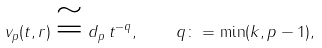<formula> <loc_0><loc_0><loc_500><loc_500>v _ { p } ( t , r ) \cong d _ { p } \, t ^ { - q } , \quad q \colon = \min ( k , p - 1 ) ,</formula> 